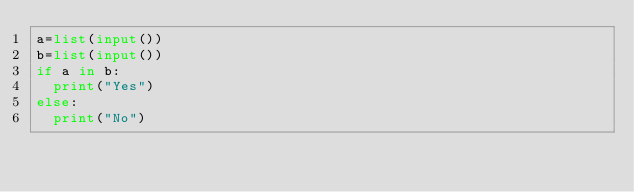<code> <loc_0><loc_0><loc_500><loc_500><_Python_>a=list(input())
b=list(input())
if a in b:
  print("Yes")
else:
  print("No")</code> 